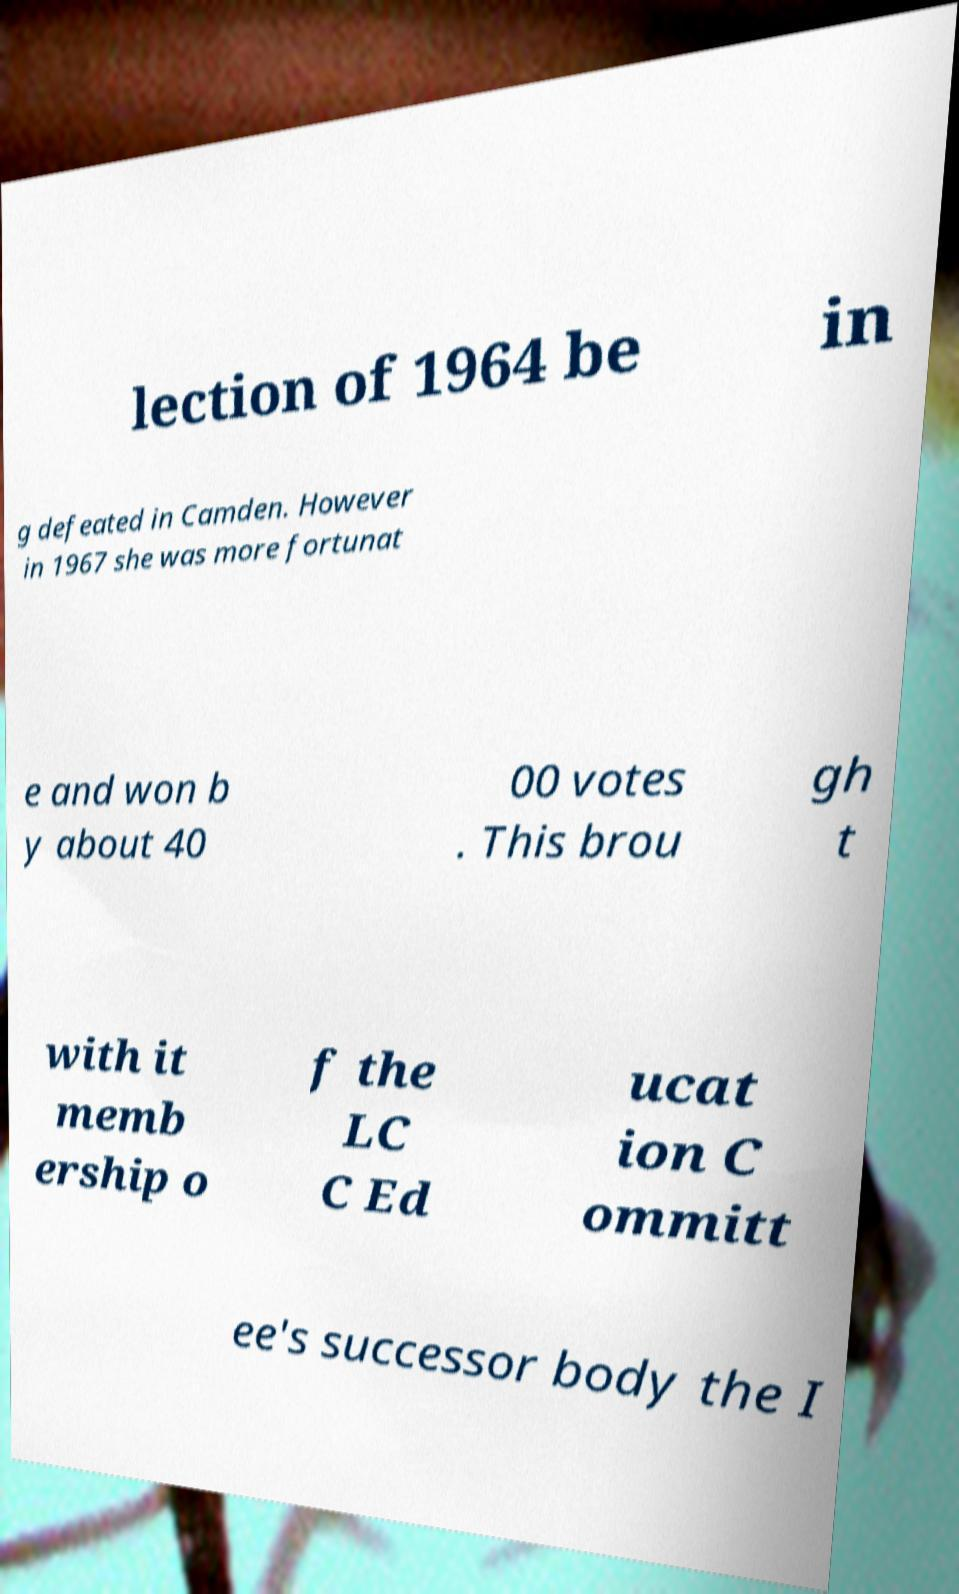There's text embedded in this image that I need extracted. Can you transcribe it verbatim? lection of 1964 be in g defeated in Camden. However in 1967 she was more fortunat e and won b y about 40 00 votes . This brou gh t with it memb ership o f the LC C Ed ucat ion C ommitt ee's successor body the I 